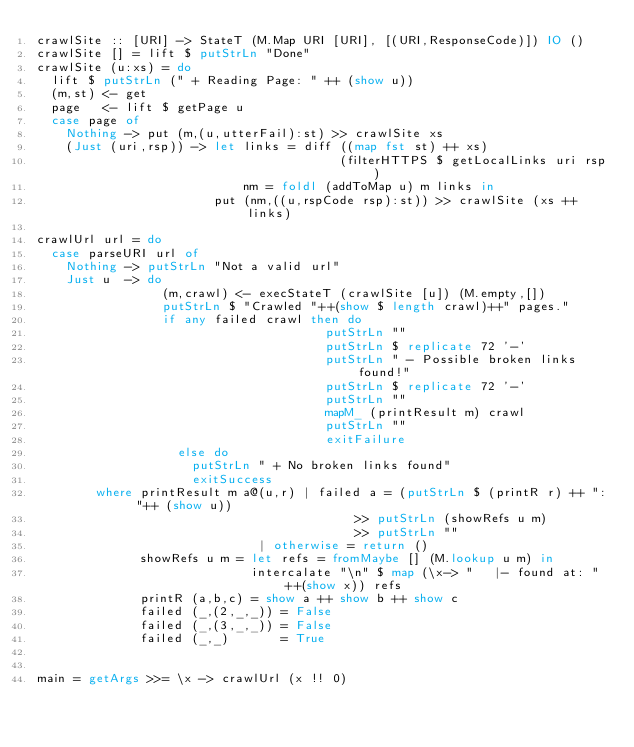<code> <loc_0><loc_0><loc_500><loc_500><_Haskell_>crawlSite :: [URI] -> StateT (M.Map URI [URI], [(URI,ResponseCode)]) IO ()
crawlSite [] = lift $ putStrLn "Done"
crawlSite (u:xs) = do
  lift $ putStrLn (" + Reading Page: " ++ (show u))
  (m,st) <- get
  page   <- lift $ getPage u
  case page of 
    Nothing -> put (m,(u,utterFail):st) >> crawlSite xs
    (Just (uri,rsp)) -> let links = diff ((map fst st) ++ xs) 
                                         (filterHTTPS $ getLocalLinks uri rsp)
                            nm = foldl (addToMap u) m links in
                        put (nm,((u,rspCode rsp):st)) >> crawlSite (xs ++ links)
          
crawlUrl url = do 
  case parseURI url of
    Nothing -> putStrLn "Not a valid url"
    Just u  -> do
                 (m,crawl) <- execStateT (crawlSite [u]) (M.empty,[])
                 putStrLn $ "Crawled "++(show $ length crawl)++" pages."
                 if any failed crawl then do
                                       putStrLn "" 
                                       putStrLn $ replicate 72 '-' 
                                       putStrLn " - Possible broken links found!" 
                                       putStrLn $ replicate 72 '-' 
                                       putStrLn "" 
                                       mapM_ (printResult m) crawl
                                       putStrLn "" 
                                       exitFailure
                   else do
                     putStrLn " + No broken links found"
                     exitSuccess
        where printResult m a@(u,r) | failed a = (putStrLn $ (printR r) ++ ": "++ (show u)) 
                                           >> putStrLn (showRefs u m) 
                                           >> putStrLn ""
                              | otherwise = return ()
              showRefs u m = let refs = fromMaybe [] (M.lookup u m) in 
                             intercalate "\n" $ map (\x-> "   |- found at: "++(show x)) refs
              printR (a,b,c) = show a ++ show b ++ show c
              failed (_,(2,_,_)) = False
              failed (_,(3,_,_)) = False
              failed (_,_)       = True

             
main = getArgs >>= \x -> crawlUrl (x !! 0)

</code> 